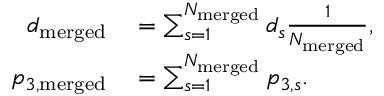Convert formula to latex. <formula><loc_0><loc_0><loc_500><loc_500>\begin{array} { r l } { d _ { m e r g e d } } & = \sum _ { s = 1 } ^ { N _ { m e r g e d } } { d _ { s } } \frac { 1 } { N _ { m e r g e d } } , } \\ { p _ { 3 , { m e r g e d } } } & = \sum _ { s = 1 } ^ { N _ { m e r g e d } } { p _ { 3 , s } } . } \end{array}</formula> 